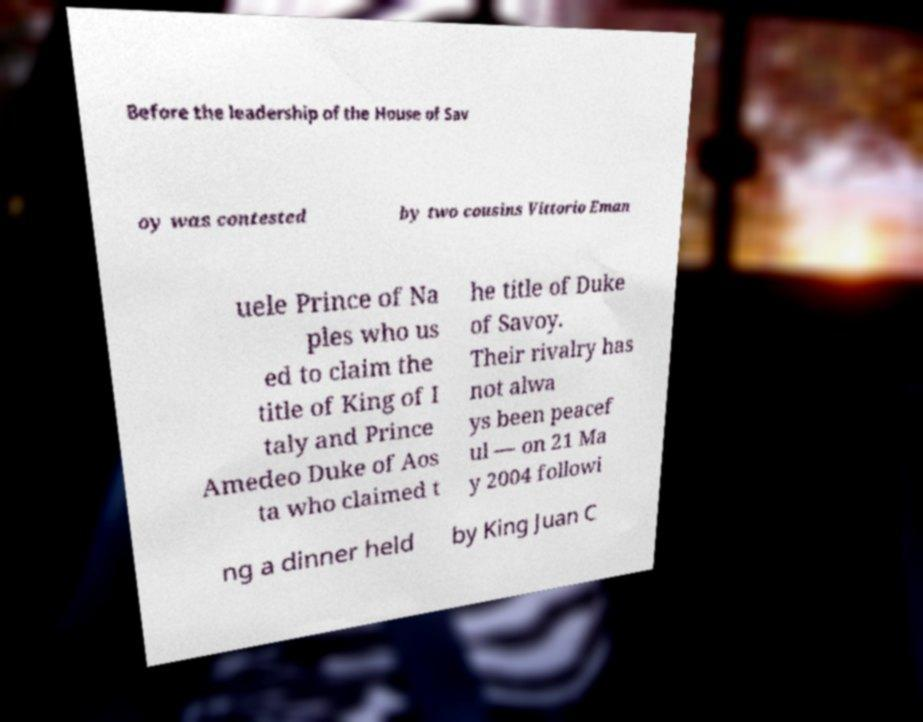Please identify and transcribe the text found in this image. Before the leadership of the House of Sav oy was contested by two cousins Vittorio Eman uele Prince of Na ples who us ed to claim the title of King of I taly and Prince Amedeo Duke of Aos ta who claimed t he title of Duke of Savoy. Their rivalry has not alwa ys been peacef ul — on 21 Ma y 2004 followi ng a dinner held by King Juan C 